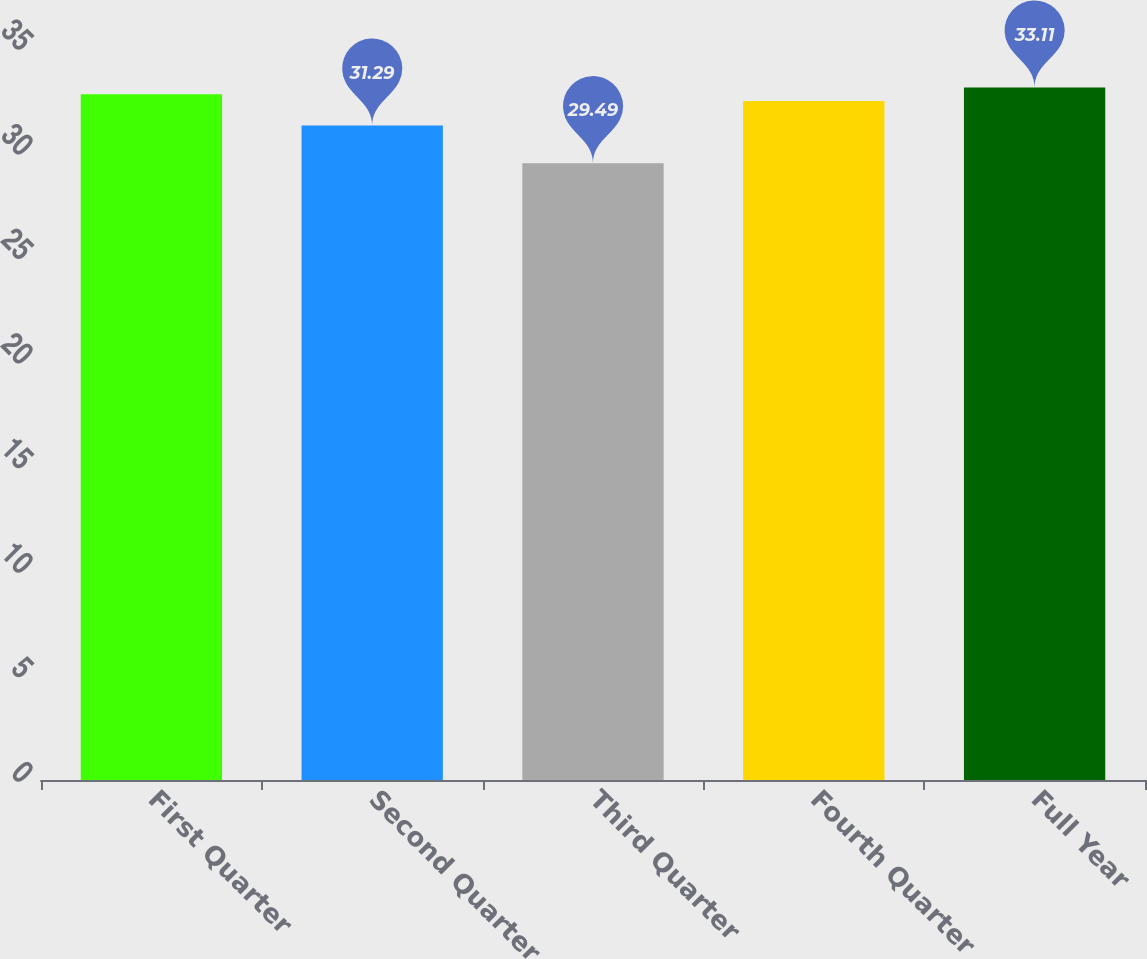<chart> <loc_0><loc_0><loc_500><loc_500><bar_chart><fcel>First Quarter<fcel>Second Quarter<fcel>Third Quarter<fcel>Fourth Quarter<fcel>Full Year<nl><fcel>32.79<fcel>31.29<fcel>29.49<fcel>32.47<fcel>33.11<nl></chart> 